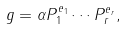Convert formula to latex. <formula><loc_0><loc_0><loc_500><loc_500>g = \alpha P _ { 1 } ^ { e _ { 1 } } \cdots P _ { r } ^ { e _ { r } } ,</formula> 